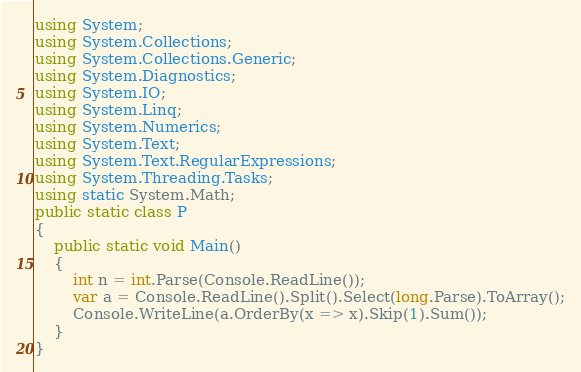<code> <loc_0><loc_0><loc_500><loc_500><_C#_>using System;
using System.Collections;
using System.Collections.Generic;
using System.Diagnostics;
using System.IO;
using System.Linq;
using System.Numerics;
using System.Text;
using System.Text.RegularExpressions;
using System.Threading.Tasks;
using static System.Math;
public static class P
{
    public static void Main()
    {
        int n = int.Parse(Console.ReadLine());
        var a = Console.ReadLine().Split().Select(long.Parse).ToArray();
        Console.WriteLine(a.OrderBy(x => x).Skip(1).Sum());
    }
}</code> 